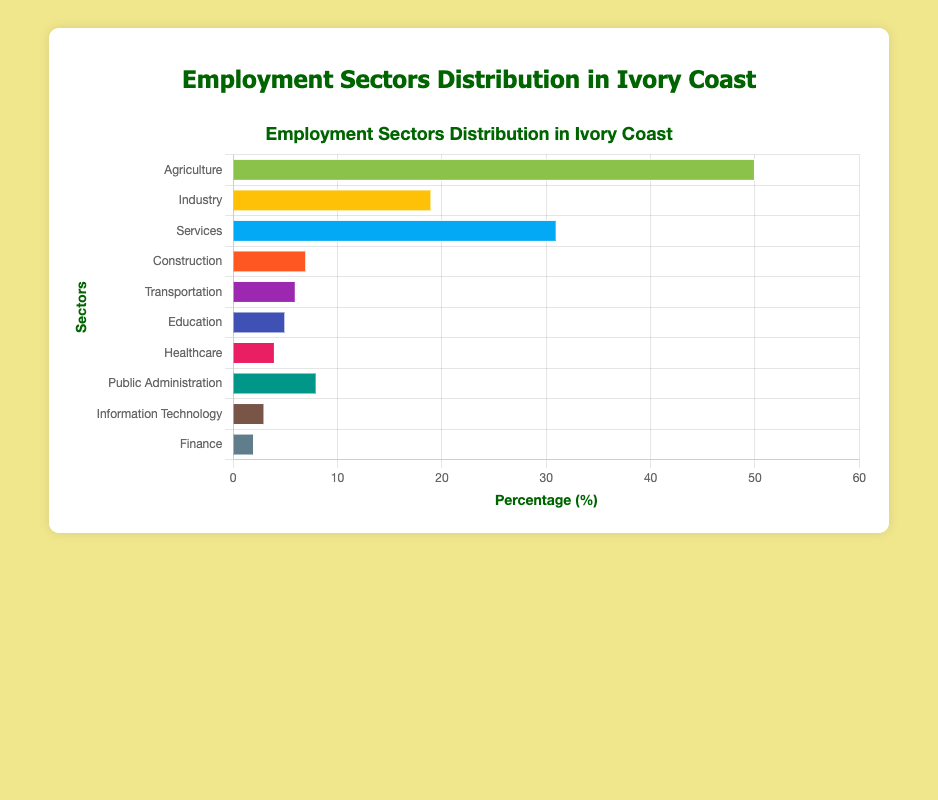What sector has the highest percentage of employment? By examining the length of the bars, the Agriculture sector has the highest percentage of employment compared to others.
Answer: Agriculture Which sectors have a percentage of employment greater than 10%? Looking at the horizontal bars, Agriculture, Industry, and Services have employment percentages greater than 10%.
Answer: Agriculture, Industry, Services What is the combined percentage of employment for Healthcare and Education? Healthcare has 4%, and Education has 5%, adding them gives 4% + 5% = 9%.
Answer: 9% Which sector has a higher percentage of employment: Construction or Transportation? By comparing the bars for Construction (7%) and Transportation (6%), Construction has a higher percentage.
Answer: Construction What is the total percentage of employment in the Finance and IT sectors? Finance has 2% and IT has 3%, combining them results in 2% + 3% = 5%.
Answer: 5% What is the difference in employment percentages between Public Administration and Services? Services have 31% and Public Administration has 8%, the difference is 31% - 8% = 23%.
Answer: 23% Which sector has the smallest percentage of employment? Observing the bar lengths, the Finance sector has the smallest percentage of employment at 2%.
Answer: Finance How much more employment percentage does the Agriculture sector have compared to the Industry sector? Agriculture has 50% while the Industry sector has 19%, so 50% - 19% = 31%.
Answer: 31% What is the average percentage of employment across all sectors? Summing up all percentages (50 + 19 + 31 + 7 + 6 + 5 + 4 + 8 + 3 + 2 = 135) and dividing by the number of sectors (10) gives 135 / 10 = 13.5%.
Answer: 13.5% If the percentage of employment in the Services sector increases by 5%, what will be the new percentage? Services currently have 31%, adding 5% results in 31% + 5% = 36%.
Answer: 36% 